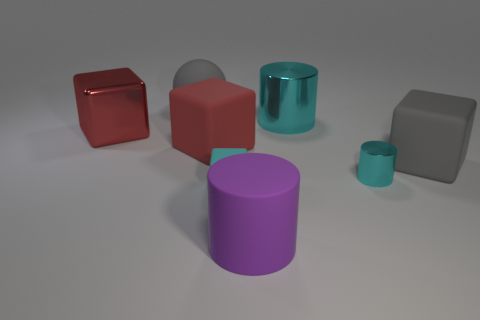Subtract all matte cubes. How many cubes are left? 1 Add 1 red metallic cubes. How many objects exist? 9 Subtract all red cylinders. How many red cubes are left? 2 Subtract all red cubes. How many cubes are left? 2 Subtract all balls. How many objects are left? 7 Subtract 0 red spheres. How many objects are left? 8 Subtract 1 cylinders. How many cylinders are left? 2 Subtract all cyan cubes. Subtract all gray cylinders. How many cubes are left? 3 Subtract all small purple balls. Subtract all metal cubes. How many objects are left? 7 Add 3 spheres. How many spheres are left? 4 